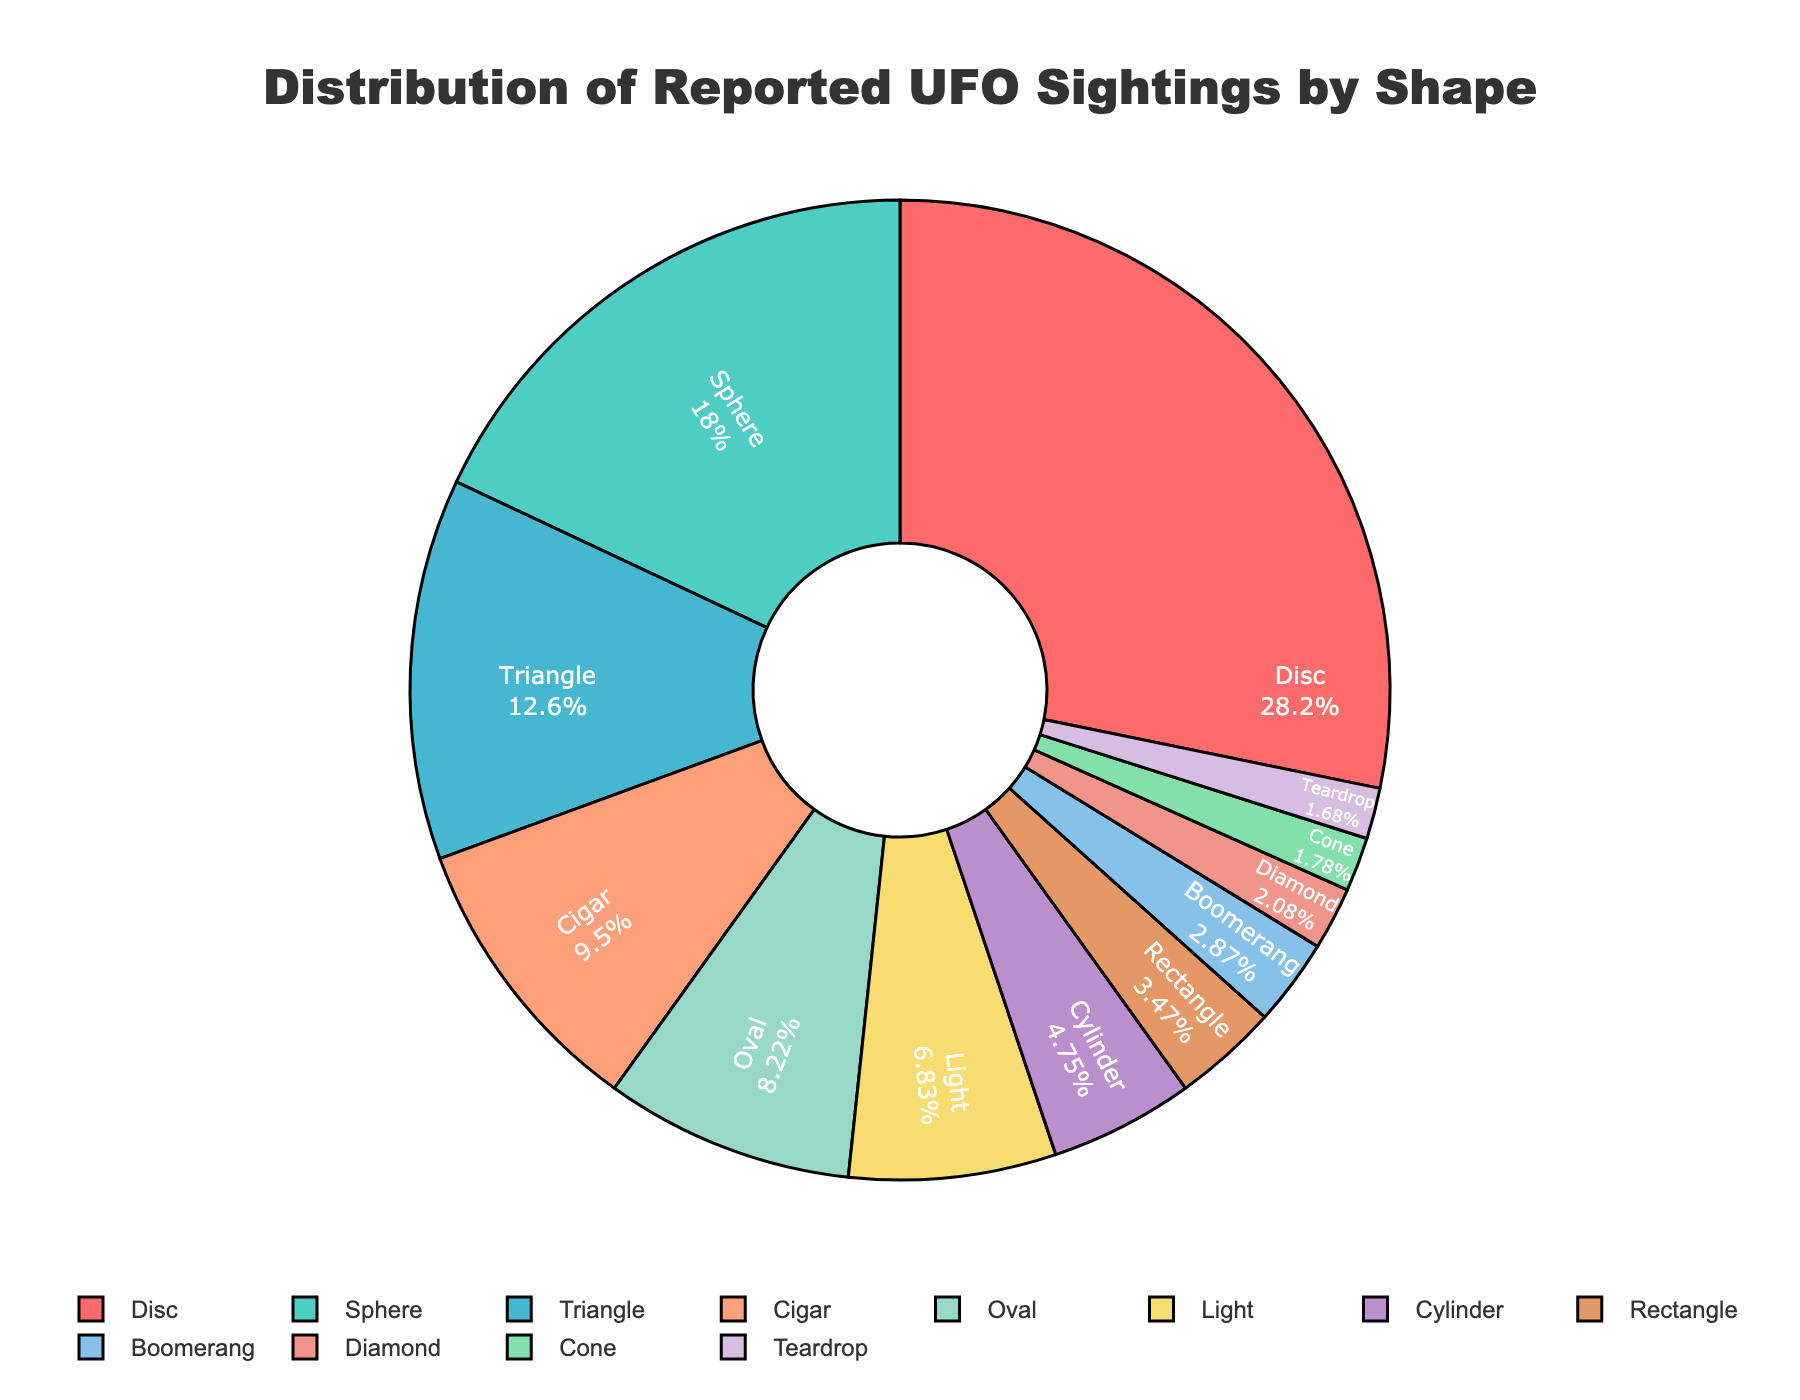Which shape classification has the highest percentage of UFO sightings? To determine the shape with the highest percentage, refer to the labels and values in the pie chart. "Disc" has the highest percentage at 28.5%.
Answer: Disc What is the combined percentage of UFO sightings classified as "Cigar" and "Oval"? Add the percentages of the "Cigar" and "Oval" shape classifications: 9.6% + 8.3% = 17.9%.
Answer: 17.9% Which shape classification has the smallest percentage of UFO sightings? To find the shape classification with the smallest percentage, look for the segment with the lowest value which is "Teardrop" at 1.7%.
Answer: Teardrop How much more frequent are "Disc" sightings compared to "Sphere" sightings? Subtract the percentage of "Sphere" sightings from "Disc" sightings: 28.5% - 18.2% = 10.3%.
Answer: 10.3% What is the total percentage of UFO sightings having shape classifications with a percentage greater than 10%? Add the percentages of "Disc", "Sphere", and "Triangle": 28.5% + 18.2% + 12.7% = 59.4%.
Answer: 59.4% How do "Cylinder" and "Rectangle" compare in terms of UFO sighting percentages? Check the percentages for "Cylinder" which is 4.8%, and "Rectangle", which is 3.5%. "Cylinder" has a higher percentage.
Answer: Cylinder What is the percentage difference between the "Boomerang" and "Diamond" shape sightings? Subtract the percentage of "Diamond" sightings from "Boomerang" sightings: 2.9% - 2.1% = 0.8%.
Answer: 0.8% Which three shape classifications have the lowest percentages, and what is their combined total? Identify the three shapes with the smallest percentages: "Diamond" (2.1%), "Cone" (1.8%), and "Teardrop" (1.7%). Add their percentages: 2.1% + 1.8% + 1.7% = 5.6%.
Answer: Diamond, Cone, Teardrop, 5.6% Which color represents the "Triangle" shape classification in the pie chart? Identify the color of the segment labeled "Triangle". It appears as a teal or light green color (#FFA07A in the generated code).
Answer: Light green Is the percentage of "Disc" sightings greater than the combined percentage of "Light" and "Cylinder" sightings? Add the percentages of "Light" and "Cylinder" sightings: 6.9% + 4.8% = 11.7%. The percentage for "Disc" is 28.5%, which is greater than 11.7%.
Answer: Yes 